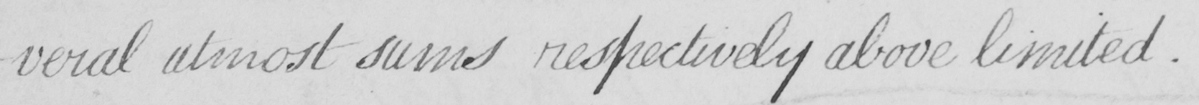Can you tell me what this handwritten text says? -veral utmost sums respectively above limited . 